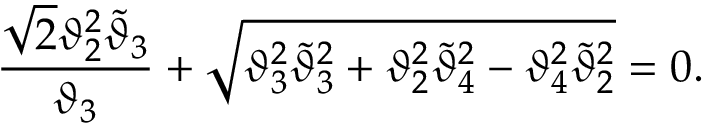<formula> <loc_0><loc_0><loc_500><loc_500>{ \frac { \sqrt { 2 } \vartheta _ { 2 } ^ { 2 } \widetilde { \vartheta } _ { 3 } } { \vartheta _ { 3 } } } + \sqrt { \vartheta _ { 3 } ^ { 2 } \widetilde { \vartheta } _ { 3 } ^ { 2 } + \vartheta _ { 2 } ^ { 2 } \widetilde { \vartheta } _ { 4 } ^ { 2 } - \vartheta _ { 4 } ^ { 2 } \widetilde { \vartheta } _ { 2 } ^ { 2 } } = 0 .</formula> 